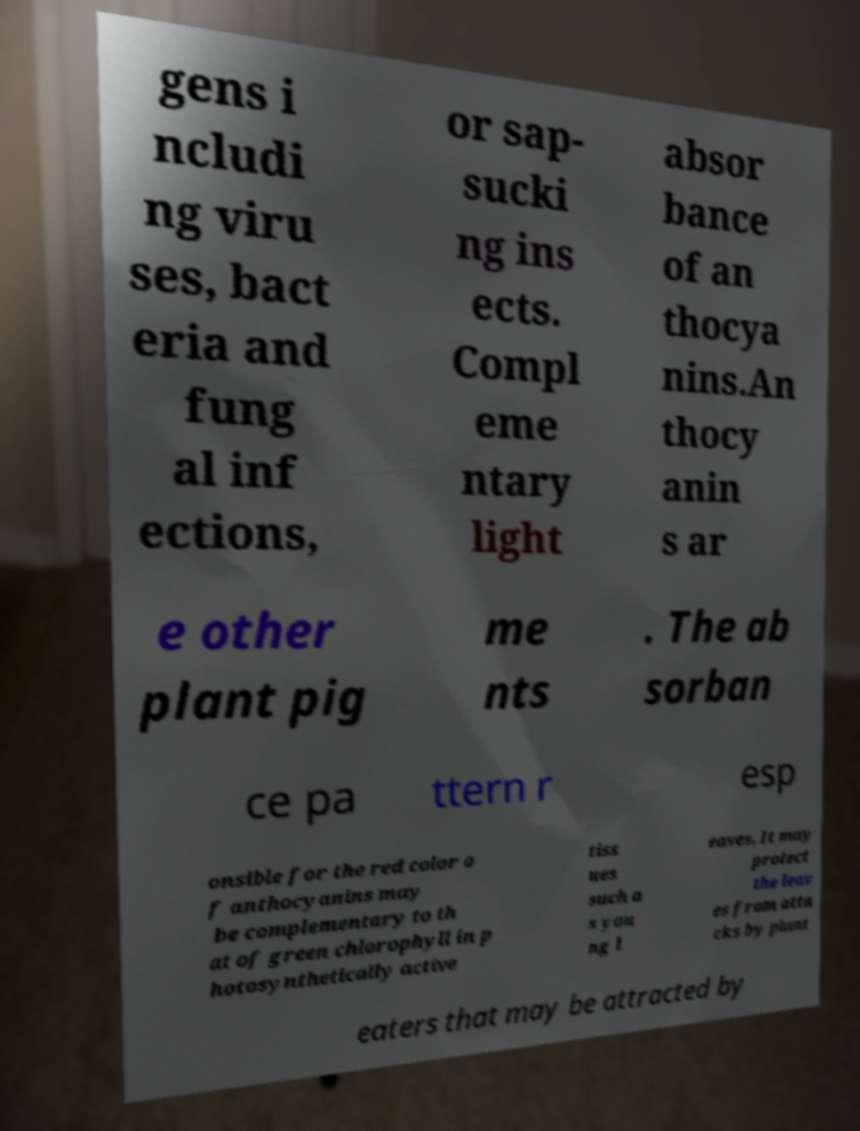Can you accurately transcribe the text from the provided image for me? gens i ncludi ng viru ses, bact eria and fung al inf ections, or sap- sucki ng ins ects. Compl eme ntary light absor bance of an thocya nins.An thocy anin s ar e other plant pig me nts . The ab sorban ce pa ttern r esp onsible for the red color o f anthocyanins may be complementary to th at of green chlorophyll in p hotosynthetically active tiss ues such a s you ng l eaves. It may protect the leav es from atta cks by plant eaters that may be attracted by 